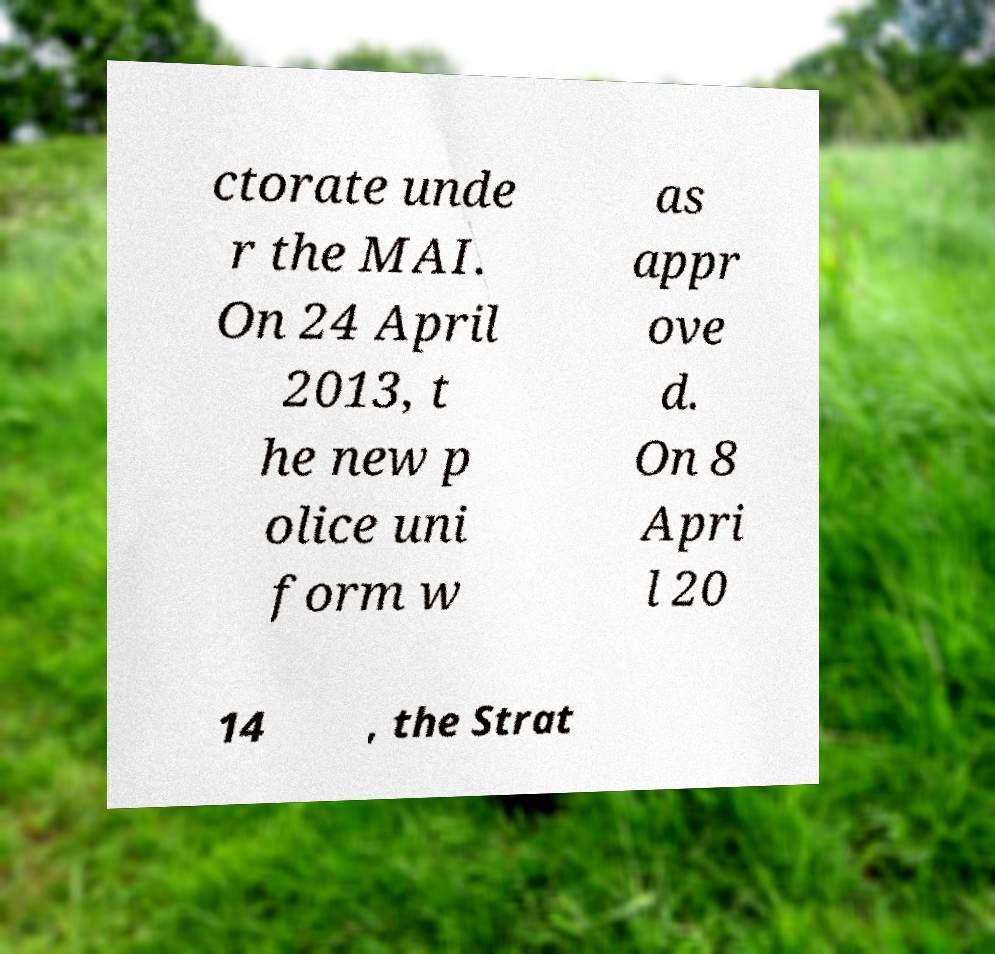Can you accurately transcribe the text from the provided image for me? ctorate unde r the MAI. On 24 April 2013, t he new p olice uni form w as appr ove d. On 8 Apri l 20 14 , the Strat 